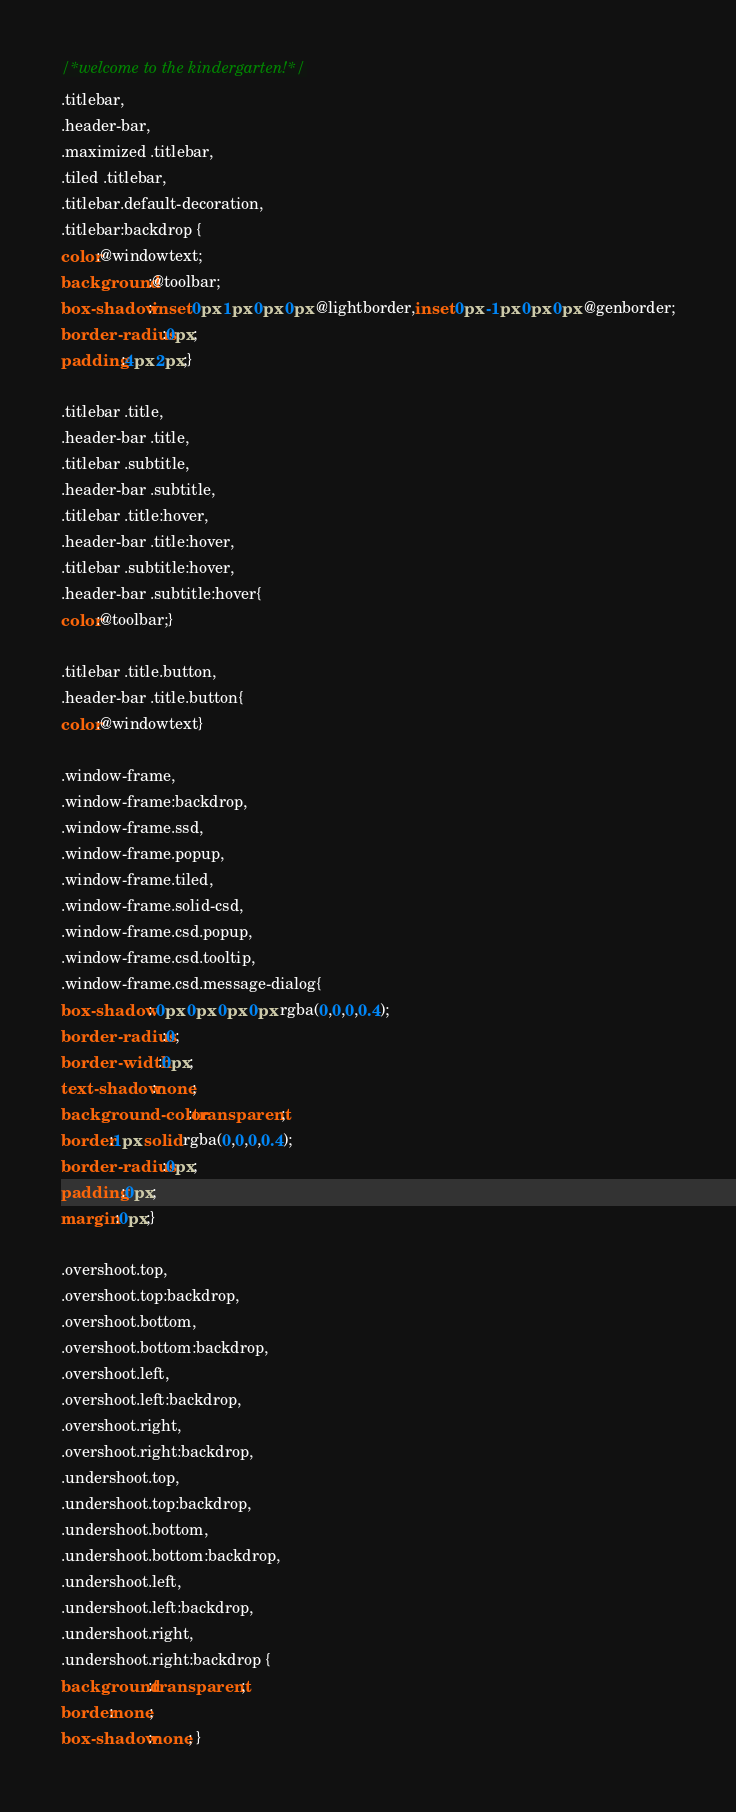<code> <loc_0><loc_0><loc_500><loc_500><_CSS_>/*welcome to the kindergarten!*/
.titlebar,
.header-bar,
.maximized .titlebar,
.tiled .titlebar,
.titlebar.default-decoration,
.titlebar:backdrop {
color:@windowtext;
background:@toolbar;
box-shadow:inset 0px 1px 0px 0px @lightborder,inset 0px -1px 0px 0px @genborder;
border-radius:0px;
padding:4px 2px;}

.titlebar .title,
.header-bar .title,
.titlebar .subtitle,
.header-bar .subtitle,
.titlebar .title:hover,
.header-bar .title:hover,
.titlebar .subtitle:hover,
.header-bar .subtitle:hover{
color:@toolbar;}

.titlebar .title.button,
.header-bar .title.button{
color:@windowtext}

.window-frame,
.window-frame:backdrop,
.window-frame.ssd,
.window-frame.popup,
.window-frame.tiled,
.window-frame.solid-csd,
.window-frame.csd.popup,
.window-frame.csd.tooltip,
.window-frame.csd.message-dialog{
box-shadow: 0px 0px 0px 0px rgba(0,0,0,0.4);
border-radius:0;
border-width:0px;
text-shadow:none;
background-color:transparent;
border:1px solid rgba(0,0,0,0.4);
border-radius:0px;
padding:0px;
margin:0px;}

.overshoot.top,
.overshoot.top:backdrop,
.overshoot.bottom,
.overshoot.bottom:backdrop,
.overshoot.left,
.overshoot.left:backdrop,
.overshoot.right,
.overshoot.right:backdrop,
.undershoot.top,
.undershoot.top:backdrop,
.undershoot.bottom,
.undershoot.bottom:backdrop,
.undershoot.left,
.undershoot.left:backdrop,
.undershoot.right,
.undershoot.right:backdrop {
background:transparent;
border:none;
box-shadow:none; }
</code> 